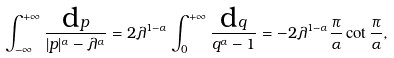<formula> <loc_0><loc_0><loc_500><loc_500>\int _ { - \infty } ^ { + \infty } \frac { { \mbox d } p } { | p | ^ { \alpha } - \lambda ^ { \alpha } } = 2 \lambda ^ { 1 - \alpha } \int _ { 0 } ^ { + \infty } \frac { { \mbox d } q } { q ^ { \alpha } - 1 } = - 2 \lambda ^ { 1 - \alpha } \frac { \pi } { \alpha } \cot { \frac { \pi } { \alpha } } ,</formula> 